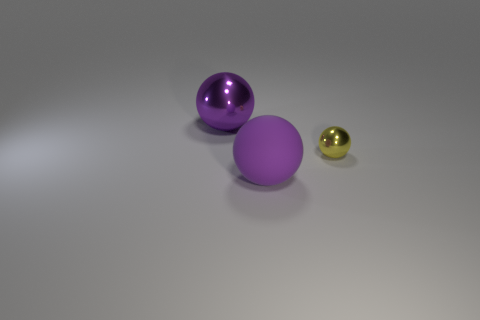Add 2 small cyan cylinders. How many objects exist? 5 Add 1 large gray cubes. How many large gray cubes exist? 1 Subtract 2 purple balls. How many objects are left? 1 Subtract all small yellow metal balls. Subtract all large spheres. How many objects are left? 0 Add 2 big purple objects. How many big purple objects are left? 4 